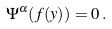Convert formula to latex. <formula><loc_0><loc_0><loc_500><loc_500>\Psi ^ { \alpha } ( f ( y ) ) = 0 \, .</formula> 